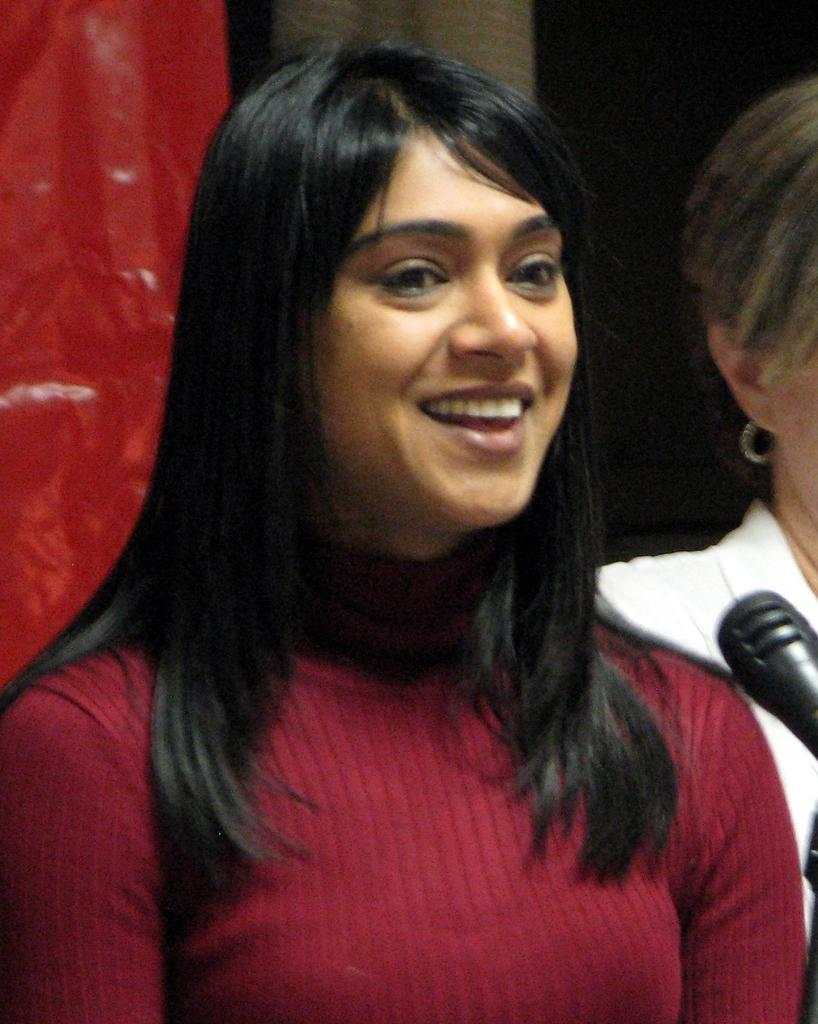How many people are in the image? There are two people in the image. What is the position of one of the people? One of the people is standing. What object is in front of the standing person? There is a microphone (mic) in front of the standing person. How many cattle are visible in the image? There are no cattle present in the image. What type of cough is the standing person exhibiting in the image? There is no indication of a cough in the image. 